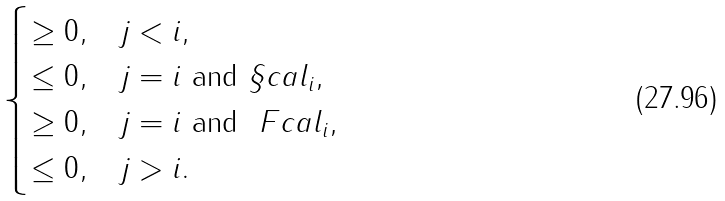Convert formula to latex. <formula><loc_0><loc_0><loc_500><loc_500>\begin{cases} \geq 0 , & j < i , \\ \leq 0 , & j = i \text { and } \S c a l _ { i } , \\ \geq 0 , & j = i \text { and } \ F c a l _ { i } , \\ \leq 0 , & j > i . \end{cases}</formula> 